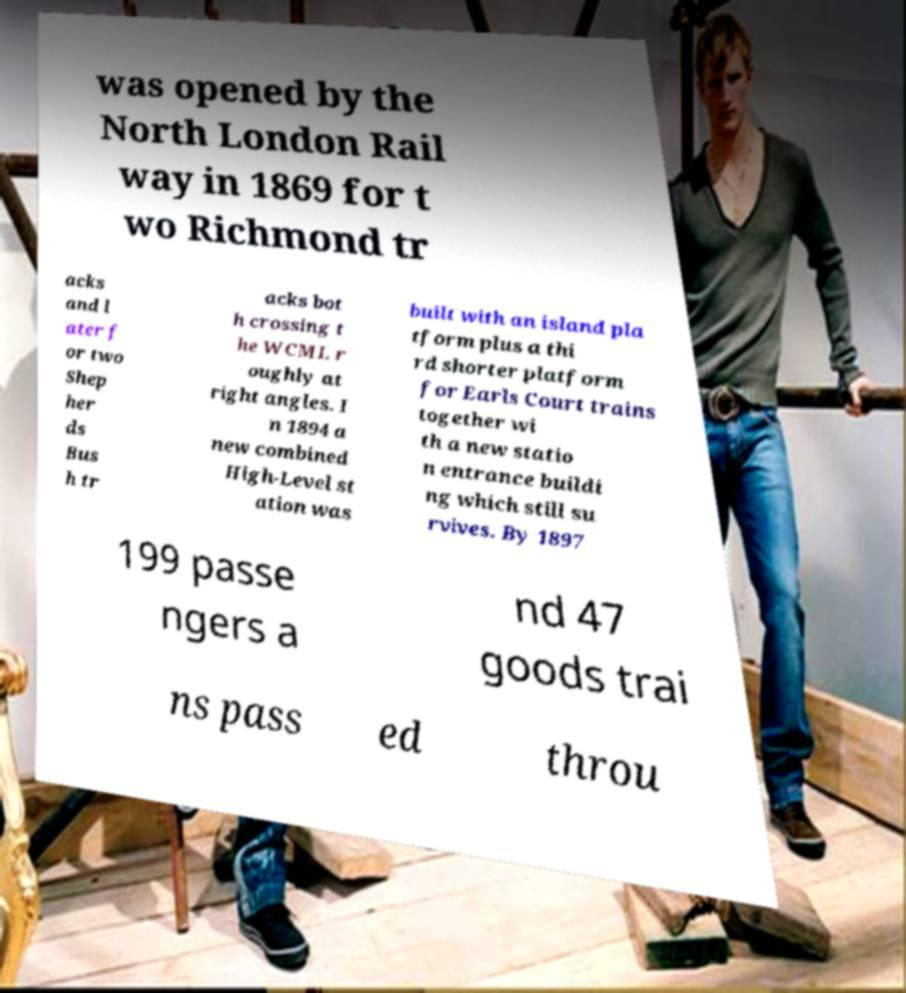Could you extract and type out the text from this image? was opened by the North London Rail way in 1869 for t wo Richmond tr acks and l ater f or two Shep her ds Bus h tr acks bot h crossing t he WCML r oughly at right angles. I n 1894 a new combined High-Level st ation was built with an island pla tform plus a thi rd shorter platform for Earls Court trains together wi th a new statio n entrance buildi ng which still su rvives. By 1897 199 passe ngers a nd 47 goods trai ns pass ed throu 